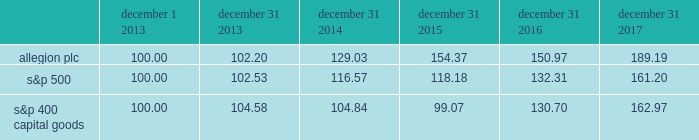Performance graph the annual changes for the period shown december 1 , 2013 ( when our ordinary shares began trading ) to december 31 , 2017 in the graph on this page are based on the assumption that $ 100 had been invested in allegion plc ordinary shares , the standard & poor 2019s 500 stock index ( "s&p 500" ) and the standard & poor's 400 capital goods index ( "s&p 400 capital goods" ) on december 1 , 2013 , and that all quarterly dividends were reinvested .
The total cumulative dollar returns shown on the graph represent the value that such investments would have had on december 31 , 2017 .
December 1 , december 31 , december 31 , december 31 , december 31 , december 31 .

Considering the final year of the investment , what was the highest return for the initial 100$ ? 
Rationale: it is the maximum value of the investment's final year .
Computations: (189.19 - 100)
Answer: 89.19. 